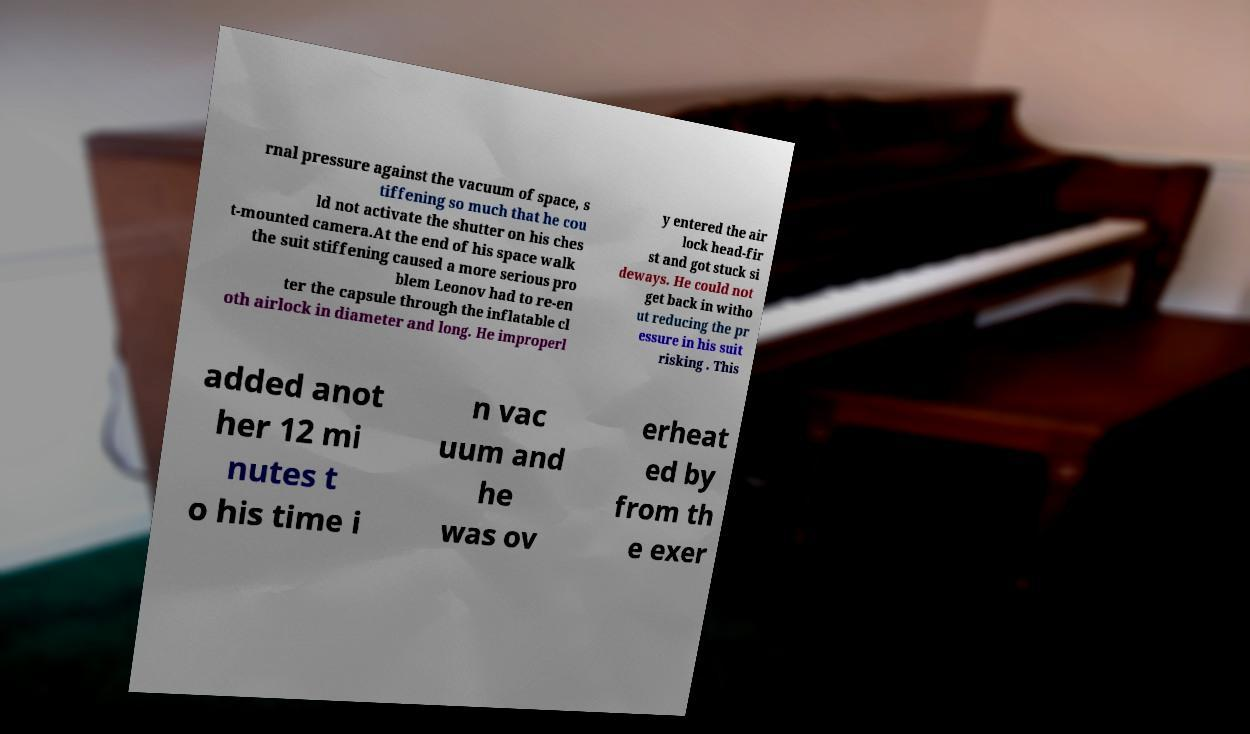Could you assist in decoding the text presented in this image and type it out clearly? rnal pressure against the vacuum of space, s tiffening so much that he cou ld not activate the shutter on his ches t-mounted camera.At the end of his space walk the suit stiffening caused a more serious pro blem Leonov had to re-en ter the capsule through the inflatable cl oth airlock in diameter and long. He improperl y entered the air lock head-fir st and got stuck si deways. He could not get back in witho ut reducing the pr essure in his suit risking . This added anot her 12 mi nutes t o his time i n vac uum and he was ov erheat ed by from th e exer 